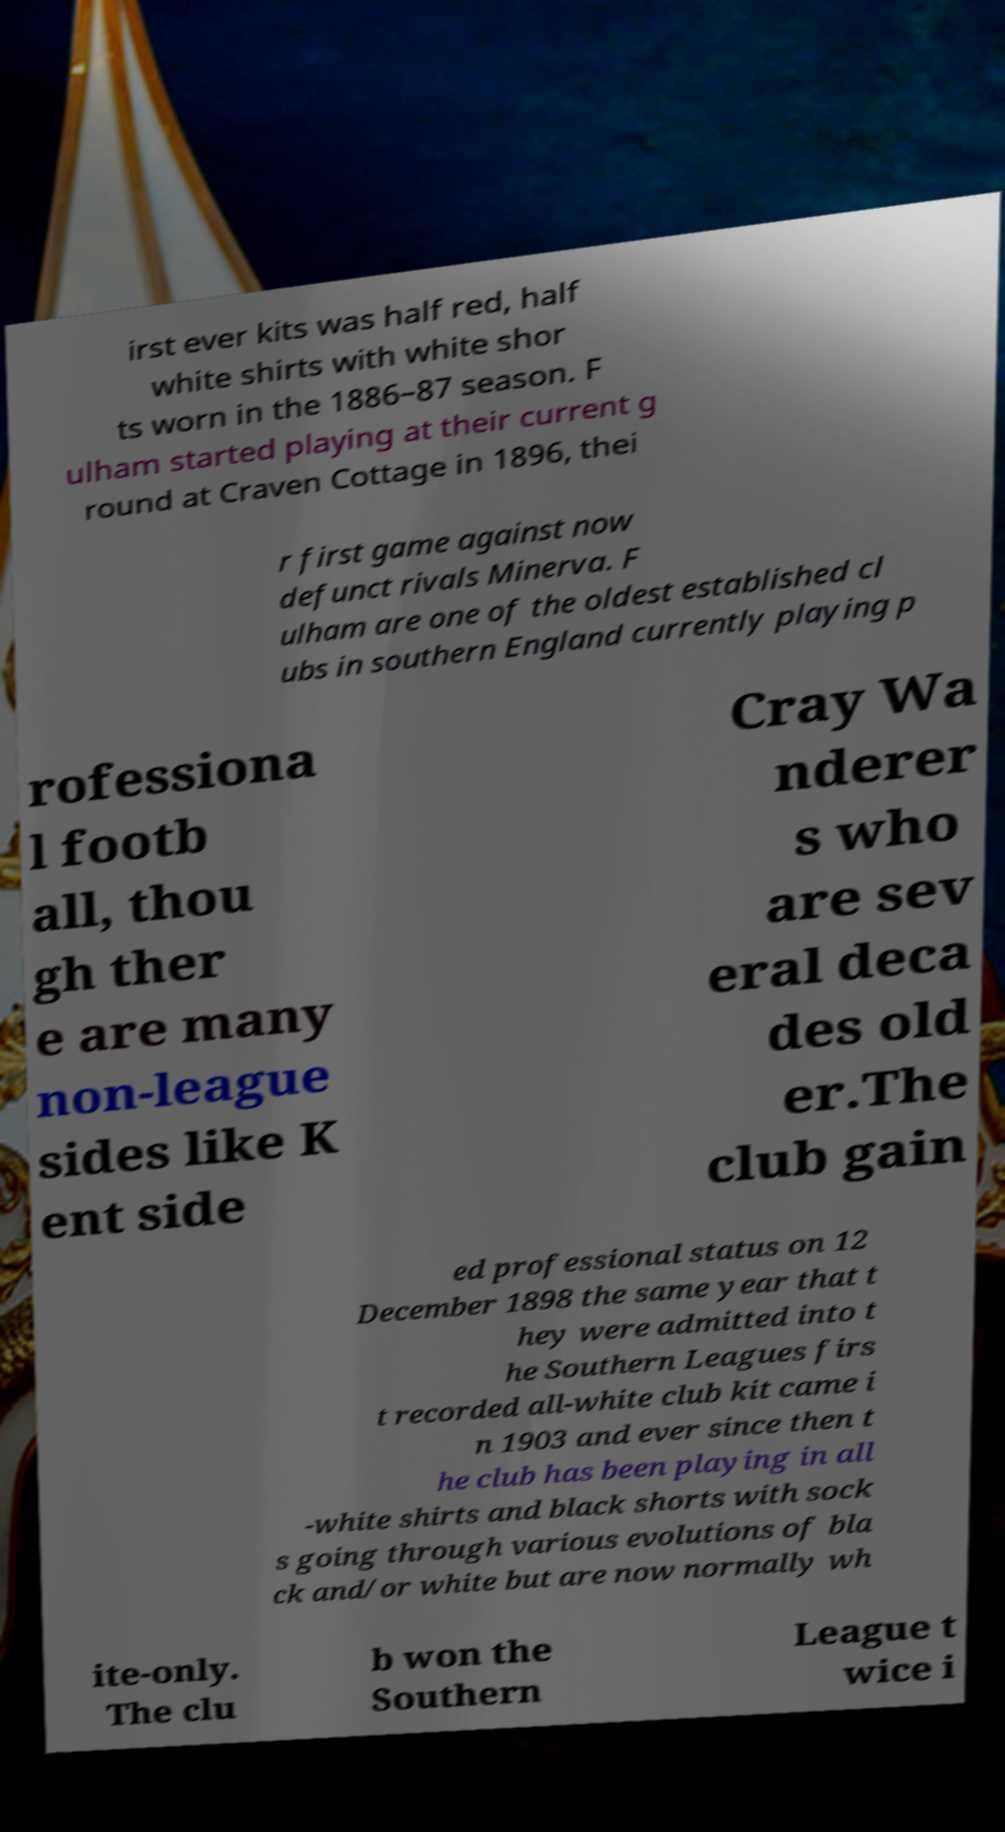I need the written content from this picture converted into text. Can you do that? irst ever kits was half red, half white shirts with white shor ts worn in the 1886–87 season. F ulham started playing at their current g round at Craven Cottage in 1896, thei r first game against now defunct rivals Minerva. F ulham are one of the oldest established cl ubs in southern England currently playing p rofessiona l footb all, thou gh ther e are many non-league sides like K ent side Cray Wa nderer s who are sev eral deca des old er.The club gain ed professional status on 12 December 1898 the same year that t hey were admitted into t he Southern Leagues firs t recorded all-white club kit came i n 1903 and ever since then t he club has been playing in all -white shirts and black shorts with sock s going through various evolutions of bla ck and/or white but are now normally wh ite-only. The clu b won the Southern League t wice i 